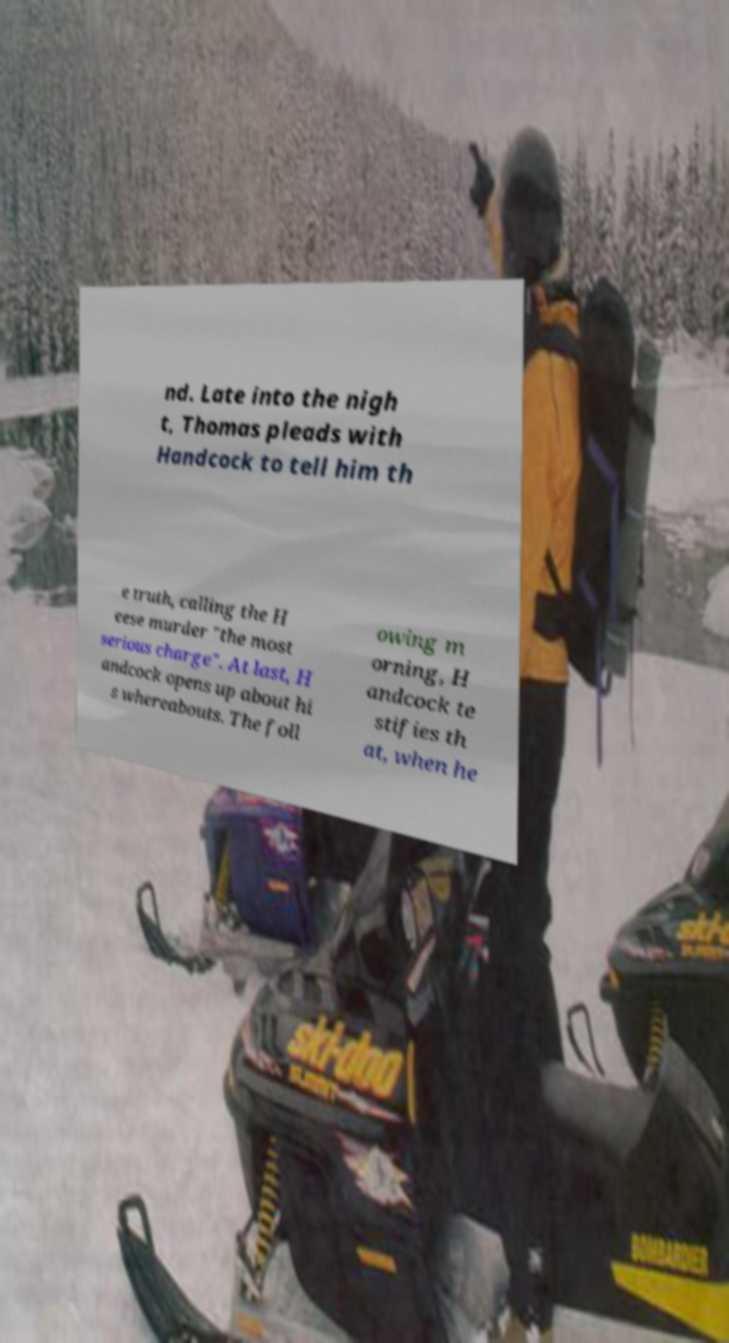There's text embedded in this image that I need extracted. Can you transcribe it verbatim? nd. Late into the nigh t, Thomas pleads with Handcock to tell him th e truth, calling the H eese murder "the most serious charge". At last, H andcock opens up about hi s whereabouts. The foll owing m orning, H andcock te stifies th at, when he 